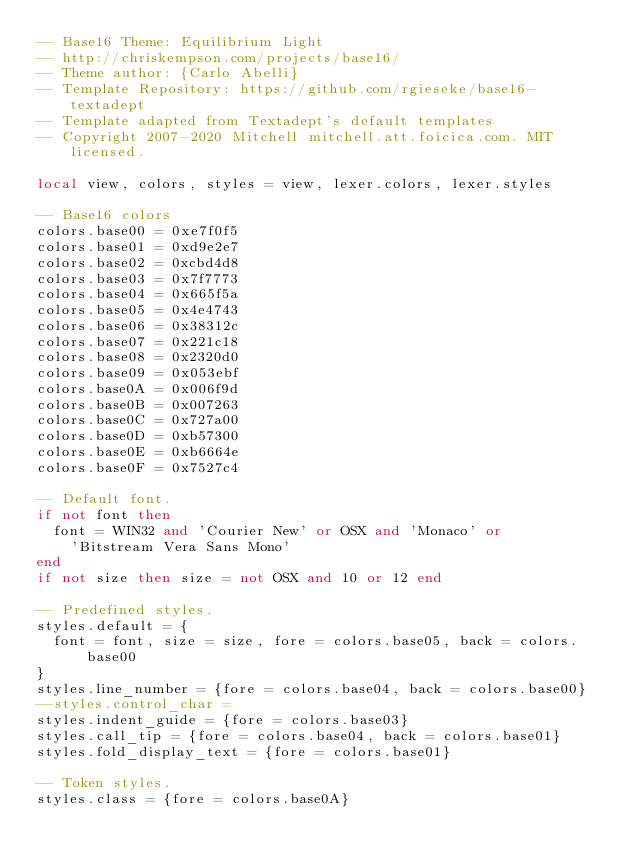<code> <loc_0><loc_0><loc_500><loc_500><_Lua_>-- Base16 Theme: Equilibrium Light
-- http://chriskempson.com/projects/base16/
-- Theme author: {Carlo Abelli}
-- Template Repository: https://github.com/rgieseke/base16-textadept
-- Template adapted from Textadept's default templates
-- Copyright 2007-2020 Mitchell mitchell.att.foicica.com. MIT licensed.

local view, colors, styles = view, lexer.colors, lexer.styles

-- Base16 colors
colors.base00 = 0xe7f0f5
colors.base01 = 0xd9e2e7
colors.base02 = 0xcbd4d8
colors.base03 = 0x7f7773
colors.base04 = 0x665f5a
colors.base05 = 0x4e4743
colors.base06 = 0x38312c
colors.base07 = 0x221c18
colors.base08 = 0x2320d0
colors.base09 = 0x053ebf
colors.base0A = 0x006f9d
colors.base0B = 0x007263
colors.base0C = 0x727a00
colors.base0D = 0xb57300
colors.base0E = 0xb6664e
colors.base0F = 0x7527c4

-- Default font.
if not font then
  font = WIN32 and 'Courier New' or OSX and 'Monaco' or
    'Bitstream Vera Sans Mono'
end
if not size then size = not OSX and 10 or 12 end

-- Predefined styles.
styles.default = {
  font = font, size = size, fore = colors.base05, back = colors.base00
}
styles.line_number = {fore = colors.base04, back = colors.base00}
--styles.control_char =
styles.indent_guide = {fore = colors.base03}
styles.call_tip = {fore = colors.base04, back = colors.base01}
styles.fold_display_text = {fore = colors.base01}

-- Token styles.
styles.class = {fore = colors.base0A}</code> 